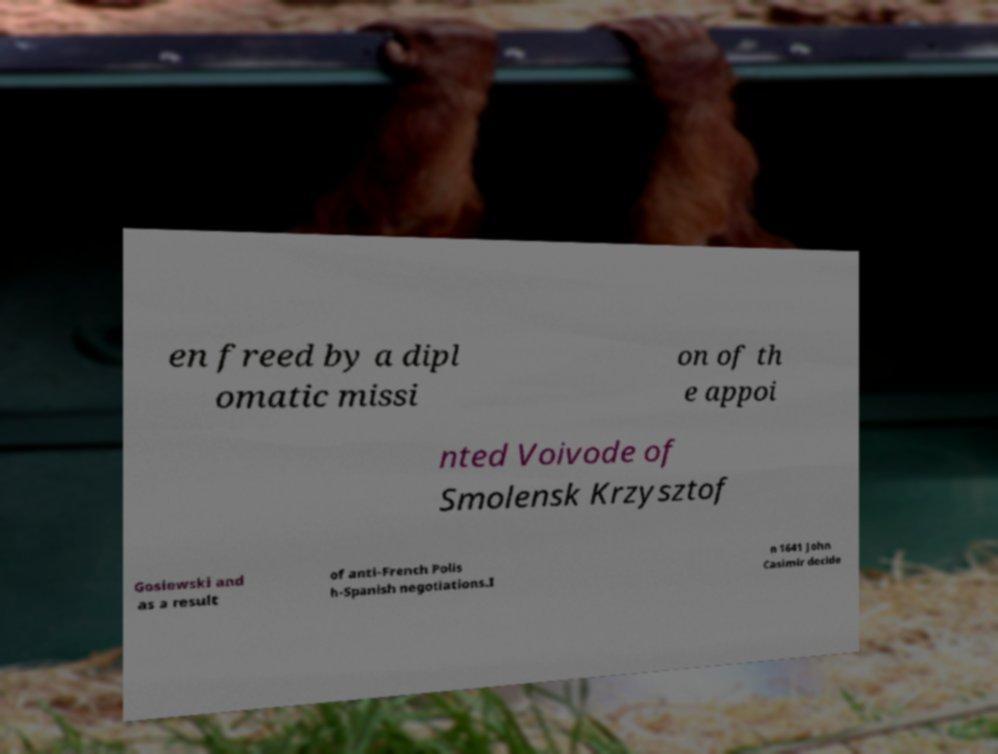For documentation purposes, I need the text within this image transcribed. Could you provide that? en freed by a dipl omatic missi on of th e appoi nted Voivode of Smolensk Krzysztof Gosiewski and as a result of anti-French Polis h-Spanish negotiations.I n 1641 John Casimir decide 